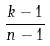<formula> <loc_0><loc_0><loc_500><loc_500>\frac { k - 1 } { n - 1 }</formula> 